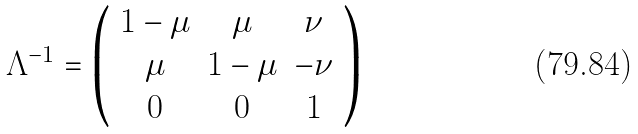Convert formula to latex. <formula><loc_0><loc_0><loc_500><loc_500>\Lambda ^ { - 1 } = \left ( \begin{array} { c c c } 1 - \mu & \mu & \nu \\ \mu & 1 - \mu & - \nu \\ 0 & 0 & 1 \end{array} \right )</formula> 